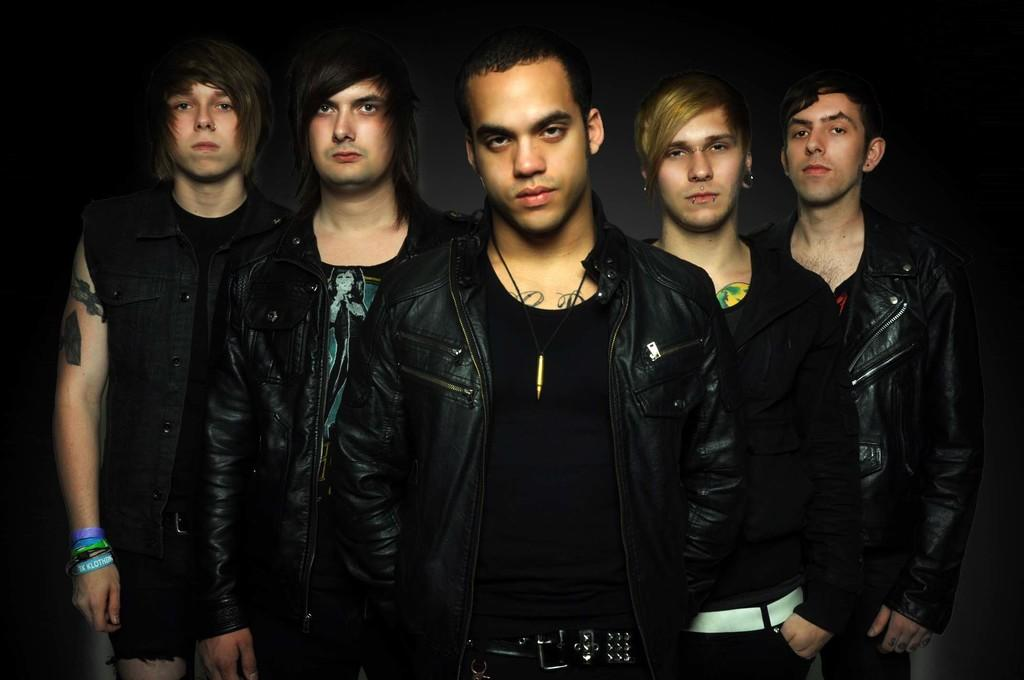How many people are in the image? There are five people in the image. What are the people wearing? The people are wearing jackets. What direction are the people looking? The people are looking forward. What is the color of the background in the image? The background of the image is black. What type of pets can be seen in the image? There are no pets visible in the image. Can you describe the intricate detail on the jackets the people are wearing? The provided facts do not mention any specific details about the jackets, so we cannot describe any intricate details. 